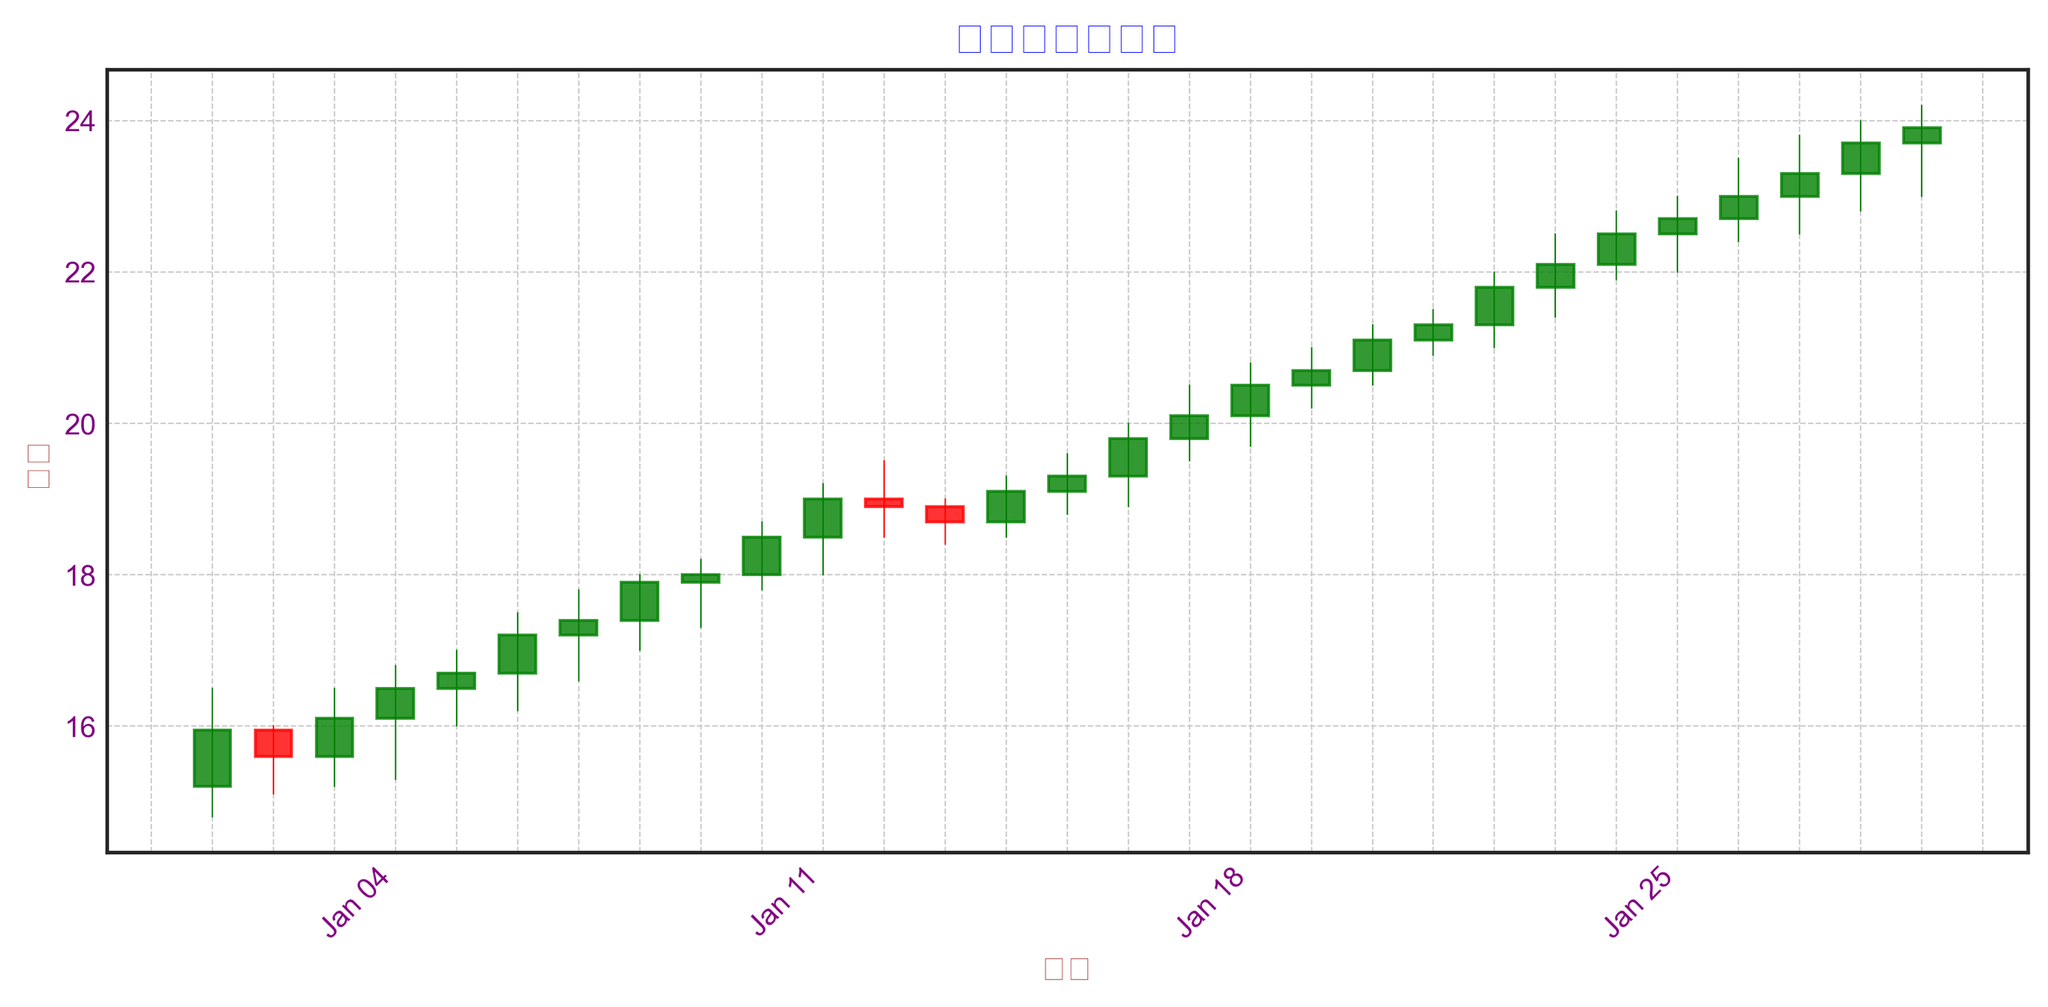Which day saw the highest closing price? From the chart, it's clear that the highest closing price is noticeable by looking at the tallest green candlestick indicating an upward trend. The highest closing price appears on January 29th, at approximately 23.90.
Answer: January 29th What's the difference in closing price between January 1st and January 20th? Look at the closing prices on January 1st and January 20th. January 1st closed at 15.95, and January 20th closed at 21.10. The difference is calculated as 21.10 - 15.95 = 5.15.
Answer: 5.15 Among January 5th, 15th, and 25th, which day had the lowest trading volume? By examining the heights of the volume bars at the bottom of the candlestick chart for these dates, January 5th has a volume of 17000, January 15th has 28000, and January 25th has 39000. Thus, January 5th has the lowest volume.
Answer: January 5th How did the volume change from January 10th to January 20th? Compare the volume bars from January 10th (23000) to January 20th (34000). Volume increased, determined by examining the height of the bars. The difference is 34000 - 23000 = 11000.
Answer: Increased by 11000 What trend is observed in closing prices from January 10th to January 19th? Analyze the daily closing prices. On January 10th, the closing price was 18.50, and on January 19th, it was 20.70. Observability shows a consistent upward trend.
Answer: Upward trend Compare the opening and closing prices on January 23rd. Is the closing price higher or lower than the opening price? January 23rd: Opening price (21.80), Closing price (22.10). The closing price is higher than the opening price, indicated by a green candlestick.
Answer: Higher What is the average closing price over the first five days of January 2021? Look at the closing prices for January 1st through 5th: 15.95, 15.60, 16.10, 16.50, 16.70. Calculate the average: (15.95 + 15.60 + 16.10 + 16.50 + 16.70) / 5 = 16.17.
Answer: 16.17 Over which days did the stock price show the most significant increase in the closing price? Compare the closing prices day by day. Notably, from January 17th (20.10) to January 18th (20.50), there is a relatively distinct rise of 0.40.
Answer: January 17th to 18th Was there any day where the stock price didn't change in terms of closing? Investigate the closing prices for consecutive days. Between January 8th and January 9th: both days closed at 18.00. Thus, the closing price didn't change.
Answer: January 8th and 9th 